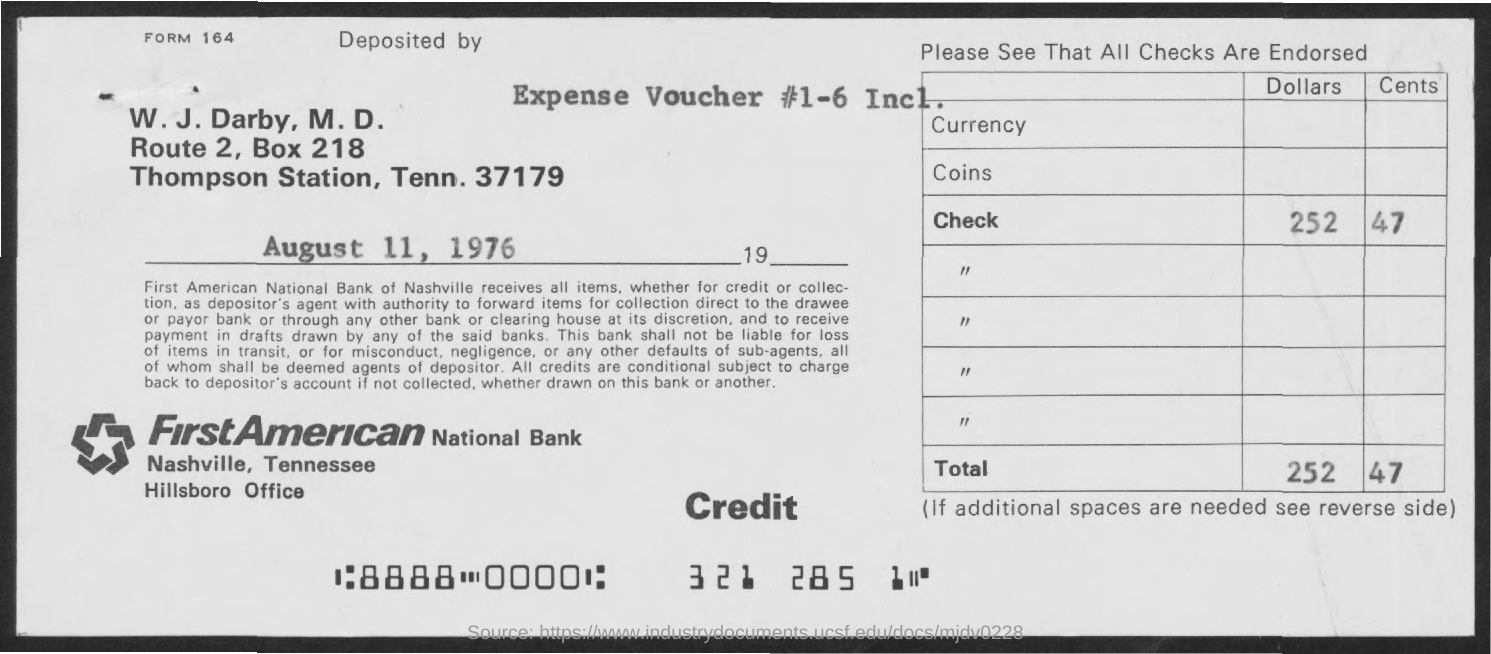What is the expense  voucher  # ?
Keep it short and to the point. 1-6 Incl. What is the BOX Number ?
Make the answer very short. 218. What is the Bank Name ?
Your response must be concise. FirstAmerican National Bank. 